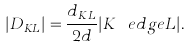<formula> <loc_0><loc_0><loc_500><loc_500>| D _ { K L } | = \frac { d _ { K L } } { 2 d } | K \ e d g e L | .</formula> 